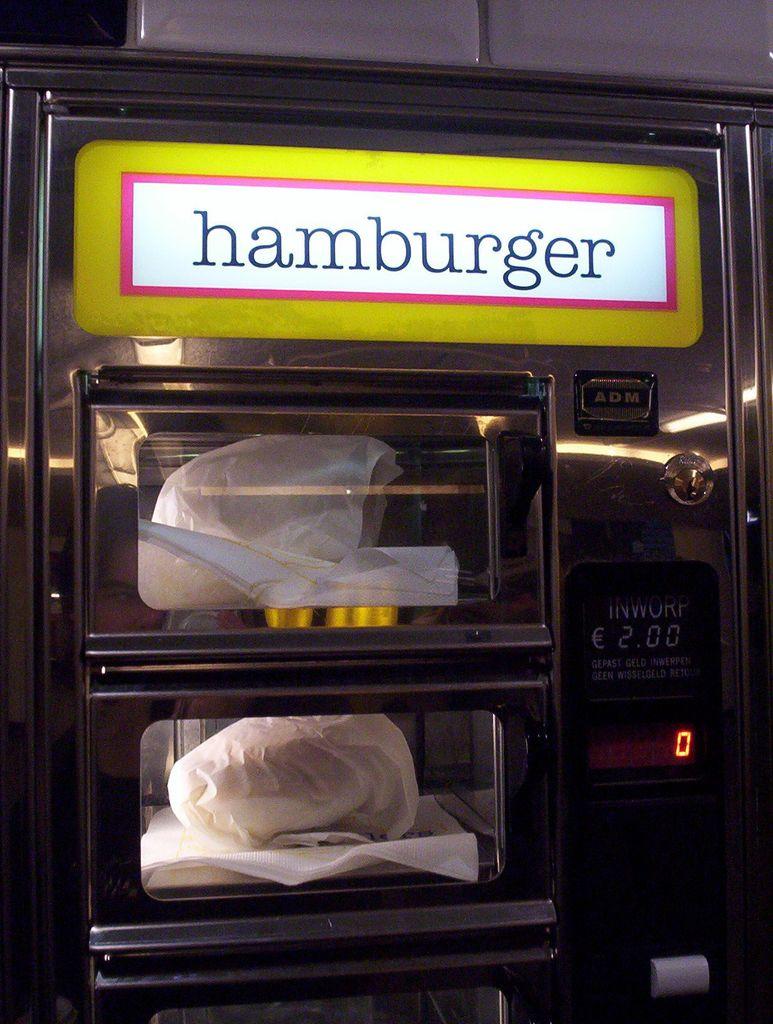How much money do i need to purchase the hamburger?
Keep it short and to the point. 2.00. 